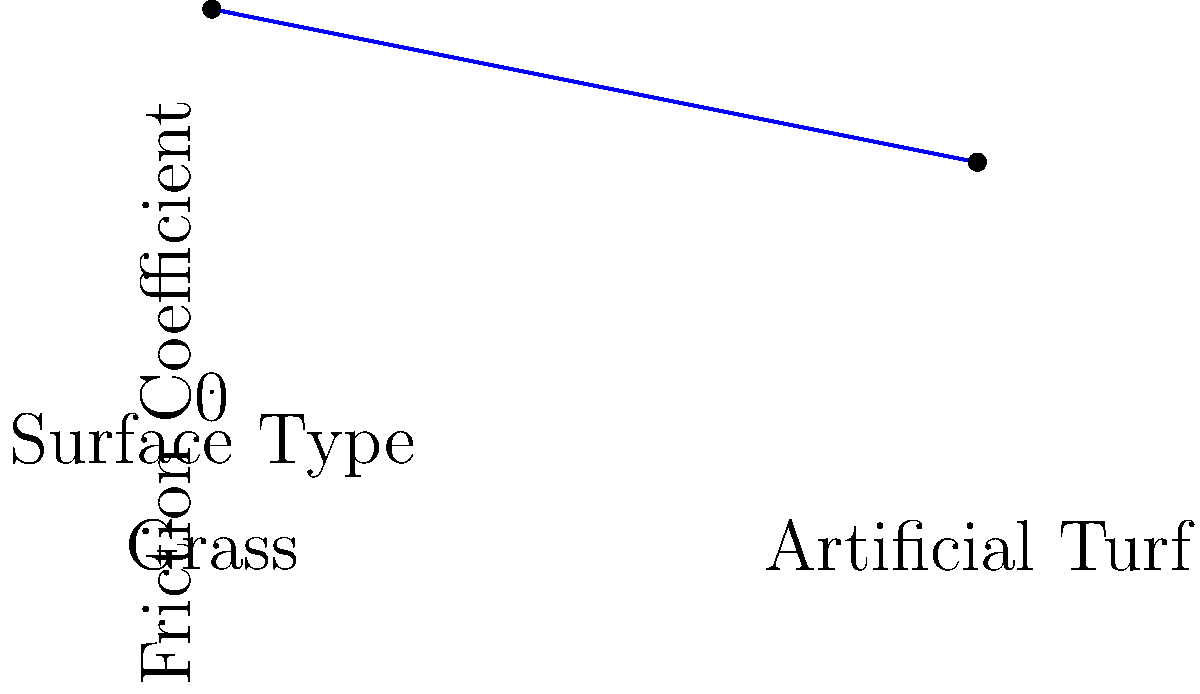Looking at this graph about field hockey, which surface seems to make the ball move more easily? Let's break this down step-by-step:

1. The graph shows the friction coefficient for two surfaces: grass and artificial turf.

2. A higher friction coefficient means more resistance to movement, while a lower friction coefficient means less resistance.

3. On the graph, we can see that:
   - Grass has a friction coefficient of about 0.5
   - Artificial turf has a friction coefficient of about 0.3

4. Since 0.3 is less than 0.5, the artificial turf has a lower friction coefficient.

5. A lower friction coefficient means less resistance to movement, so the ball would move more easily on this surface.

Therefore, based on this graph, the ball would move more easily on artificial turf.
Answer: Artificial turf 